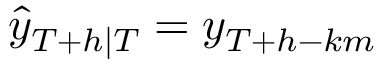Convert formula to latex. <formula><loc_0><loc_0><loc_500><loc_500>{ \hat { y } } _ { T + h | T } = y _ { T + h - k m }</formula> 